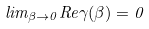<formula> <loc_0><loc_0><loc_500><loc_500>l i m _ { { \beta } \rightarrow { 0 } } R e { \gamma } ( \beta ) = 0</formula> 